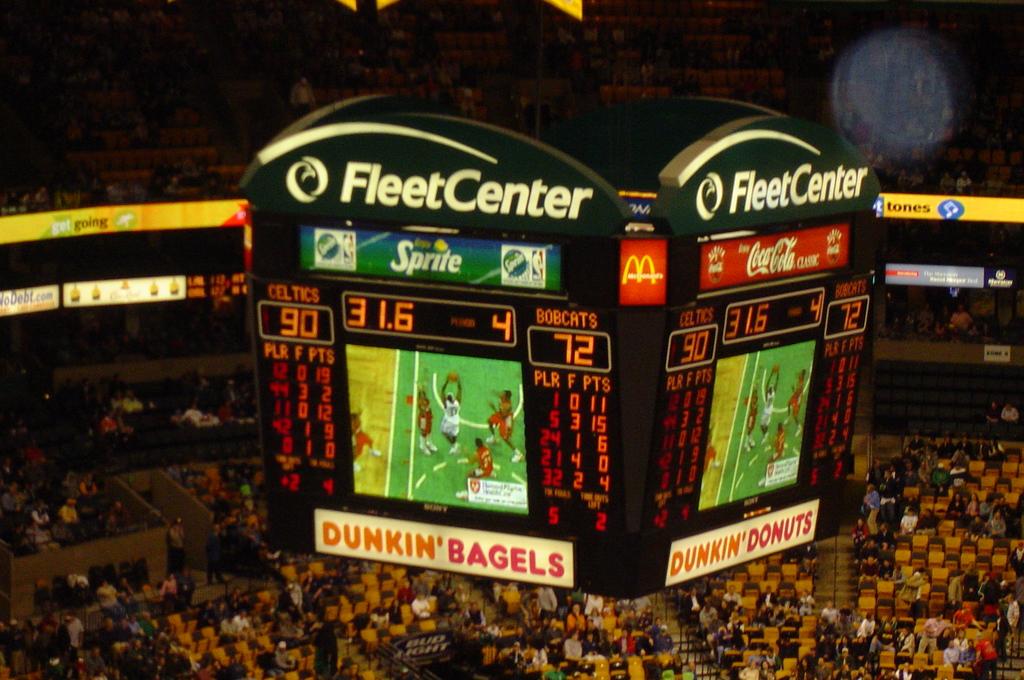How many points do the celtics have?
Give a very brief answer. 90. What is the score?
Provide a succinct answer. 90-72. 